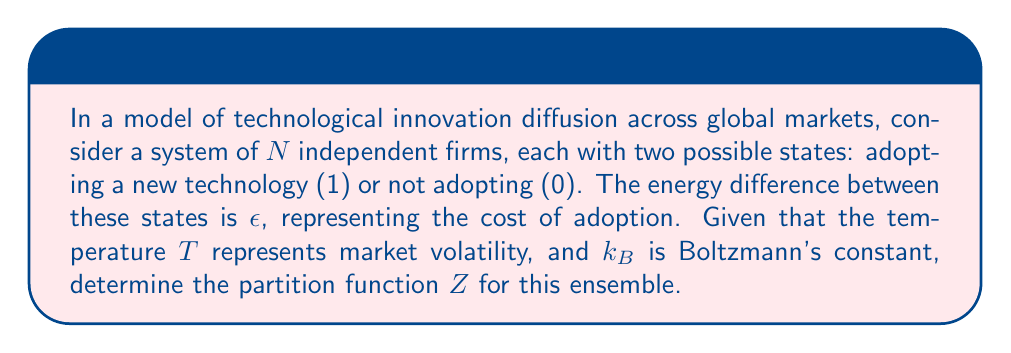Can you answer this question? To solve this problem, we'll follow these steps:

1) In statistical mechanics, the partition function $Z$ for a system of $N$ independent particles with two energy states is given by:

   $$Z = (1 + e^{-\beta\epsilon})^N$$

   where $\beta = \frac{1}{k_B T}$

2) In our case, the two states represent adopting (1) or not adopting (0) the new technology. The energy difference $\epsilon$ represents the cost of adoption.

3) We can interpret $T$ (temperature) as market volatility, with higher $T$ indicating more volatile markets.

4) Substituting these interpretations into the partition function formula:

   $$Z = (1 + e^{-\epsilon/(k_B T)})^N$$

5) This partition function represents all possible configurations of technology adoption among the $N$ firms, weighted by their probability of occurrence.

6) The term $e^{-\epsilon/(k_B T)}$ represents the probability of a firm adopting the technology relative to not adopting it. When $T$ is high (volatile market), this term approaches 1, meaning firms are more likely to adopt despite the cost. When $T$ is low (stable market), this term becomes smaller, making adoption less likely.

7) The exponent $N$ accounts for all firms in the system, assuming they make decisions independently.
Answer: $$Z = (1 + e^{-\epsilon/(k_B T)})^N$$ 